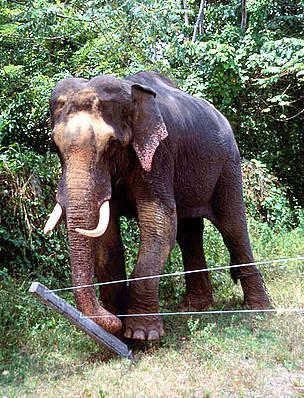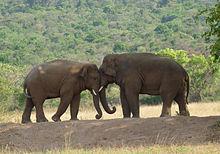The first image is the image on the left, the second image is the image on the right. Given the left and right images, does the statement "In one image, and elephant with tusks has its ears fanned out their full width." hold true? Answer yes or no. No. 